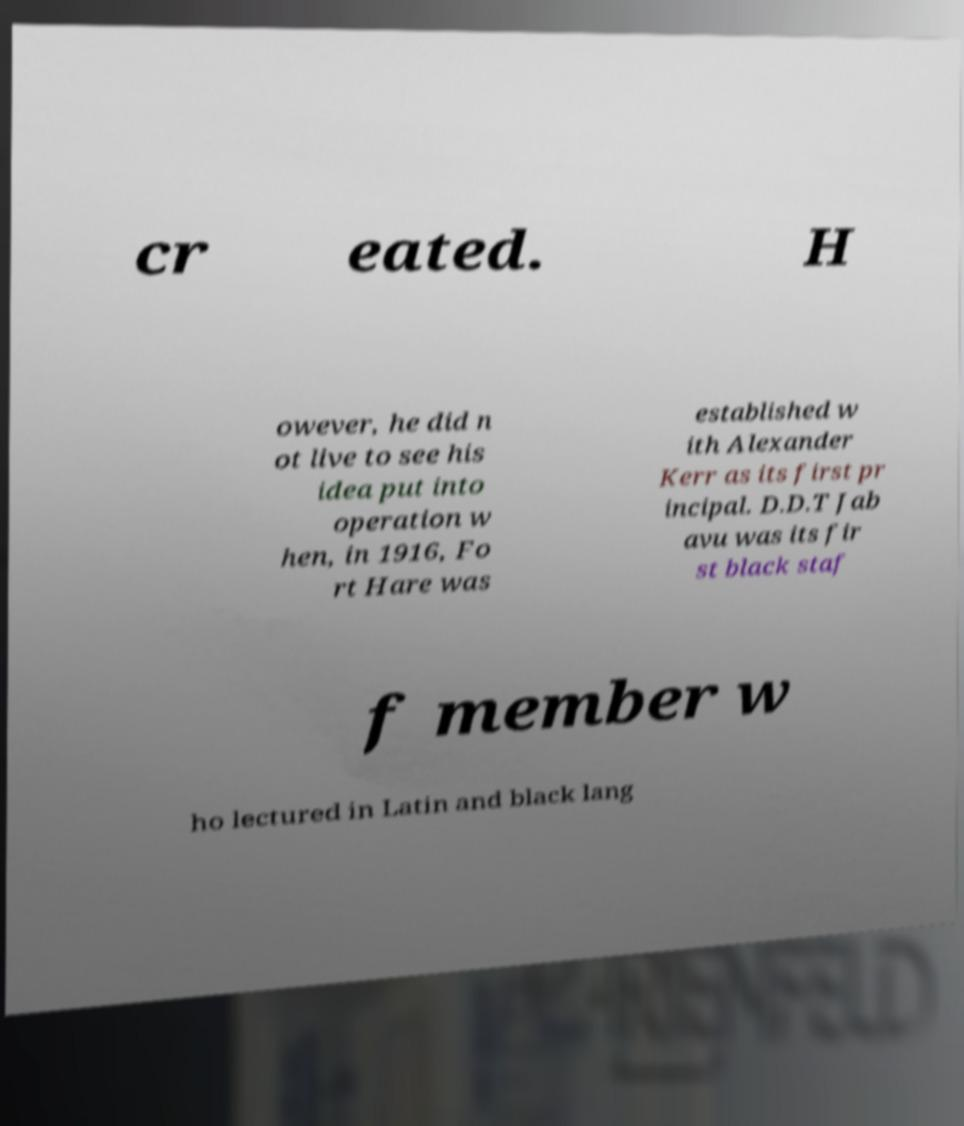Can you accurately transcribe the text from the provided image for me? cr eated. H owever, he did n ot live to see his idea put into operation w hen, in 1916, Fo rt Hare was established w ith Alexander Kerr as its first pr incipal. D.D.T Jab avu was its fir st black staf f member w ho lectured in Latin and black lang 